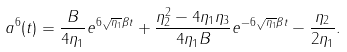<formula> <loc_0><loc_0><loc_500><loc_500>a ^ { 6 } ( t ) = \frac { B } { 4 \eta _ { 1 } } e ^ { 6 \sqrt { \eta _ { 1 } } \beta t } + \frac { \eta _ { 2 } ^ { 2 } - 4 \eta _ { 1 } \eta _ { 3 } } { 4 \eta _ { 1 } B } e ^ { - 6 \sqrt { \eta _ { 1 } } \beta t } - \frac { \eta _ { 2 } } { 2 \eta _ { 1 } } .</formula> 